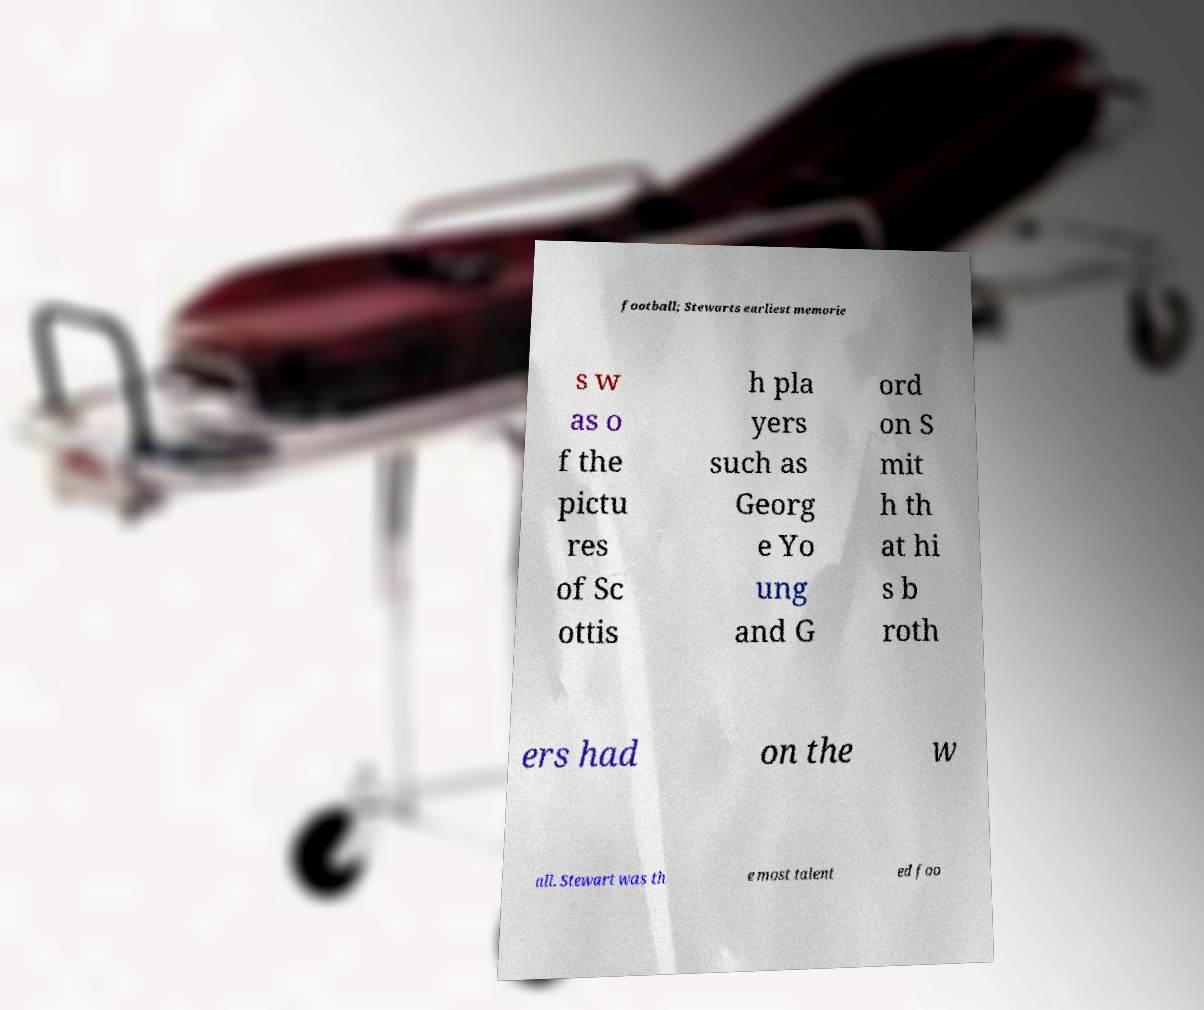I need the written content from this picture converted into text. Can you do that? football; Stewarts earliest memorie s w as o f the pictu res of Sc ottis h pla yers such as Georg e Yo ung and G ord on S mit h th at hi s b roth ers had on the w all. Stewart was th e most talent ed foo 